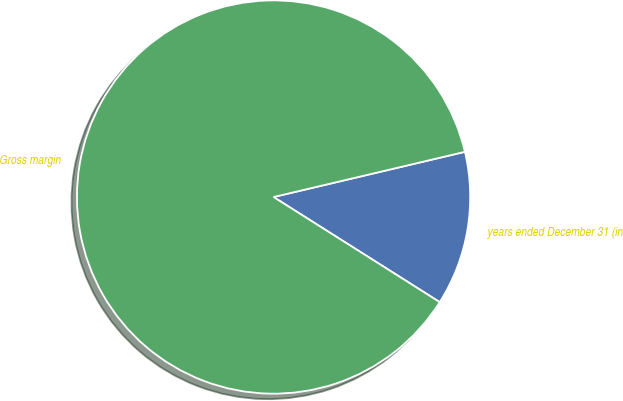Convert chart to OTSL. <chart><loc_0><loc_0><loc_500><loc_500><pie_chart><fcel>years ended December 31 (in<fcel>Gross margin<nl><fcel>12.67%<fcel>87.33%<nl></chart> 